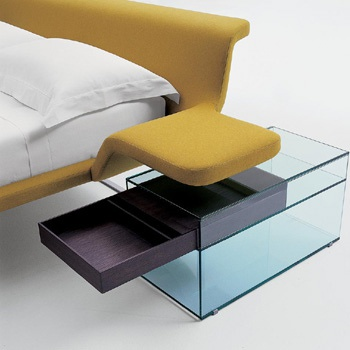Describe the objects in this image and their specific colors. I can see a bed in tan, lightgray, olive, and darkgray tones in this image. 